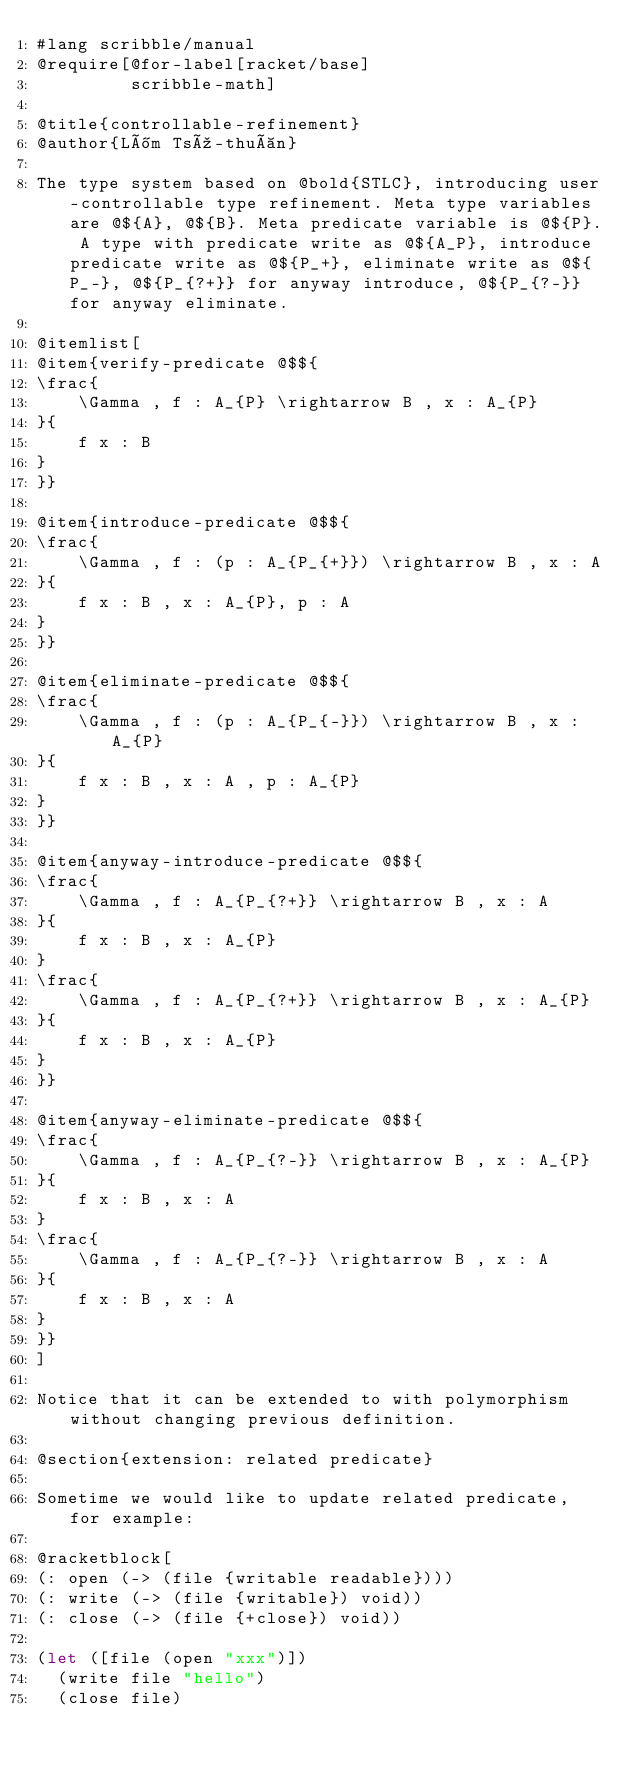<code> <loc_0><loc_0><loc_500><loc_500><_Racket_>#lang scribble/manual
@require[@for-label[racket/base]
         scribble-math]

@title{controllable-refinement}
@author{Lîm Tsú-thuàn}

The type system based on @bold{STLC}, introducing user-controllable type refinement. Meta type variables are @${A}, @${B}. Meta predicate variable is @${P}. A type with predicate write as @${A_P}, introduce predicate write as @${P_+}, eliminate write as @${P_-}, @${P_{?+}} for anyway introduce, @${P_{?-}} for anyway eliminate.

@itemlist[
@item{verify-predicate @$${
\frac{
    \Gamma , f : A_{P} \rightarrow B , x : A_{P}
}{
    f x : B
}
}}

@item{introduce-predicate @$${
\frac{
    \Gamma , f : (p : A_{P_{+}}) \rightarrow B , x : A
}{
    f x : B , x : A_{P}, p : A
}
}}

@item{eliminate-predicate @$${
\frac{
    \Gamma , f : (p : A_{P_{-}}) \rightarrow B , x : A_{P}
}{
    f x : B , x : A , p : A_{P}
}
}}

@item{anyway-introduce-predicate @$${
\frac{
    \Gamma , f : A_{P_{?+}} \rightarrow B , x : A
}{
    f x : B , x : A_{P}
}
\frac{
    \Gamma , f : A_{P_{?+}} \rightarrow B , x : A_{P}
}{
    f x : B , x : A_{P}
}
}}

@item{anyway-eliminate-predicate @$${
\frac{
    \Gamma , f : A_{P_{?-}} \rightarrow B , x : A_{P}
}{
    f x : B , x : A
}
\frac{
    \Gamma , f : A_{P_{?-}} \rightarrow B , x : A
}{
    f x : B , x : A
}
}}
]

Notice that it can be extended to with polymorphism without changing previous definition.

@section{extension: related predicate}

Sometime we would like to update related predicate, for example:

@racketblock[
(: open (-> (file {writable readable})))
(: write (-> (file {writable}) void))
(: close (-> (file {+close}) void))

(let ([file (open "xxx")])
  (write file "hello")
  (close file)</code> 